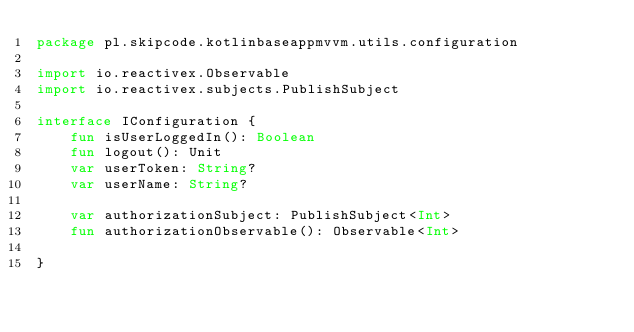Convert code to text. <code><loc_0><loc_0><loc_500><loc_500><_Kotlin_>package pl.skipcode.kotlinbaseappmvvm.utils.configuration

import io.reactivex.Observable
import io.reactivex.subjects.PublishSubject

interface IConfiguration {
    fun isUserLoggedIn(): Boolean
    fun logout(): Unit
    var userToken: String?
    var userName: String?

    var authorizationSubject: PublishSubject<Int>
    fun authorizationObservable(): Observable<Int>

}</code> 